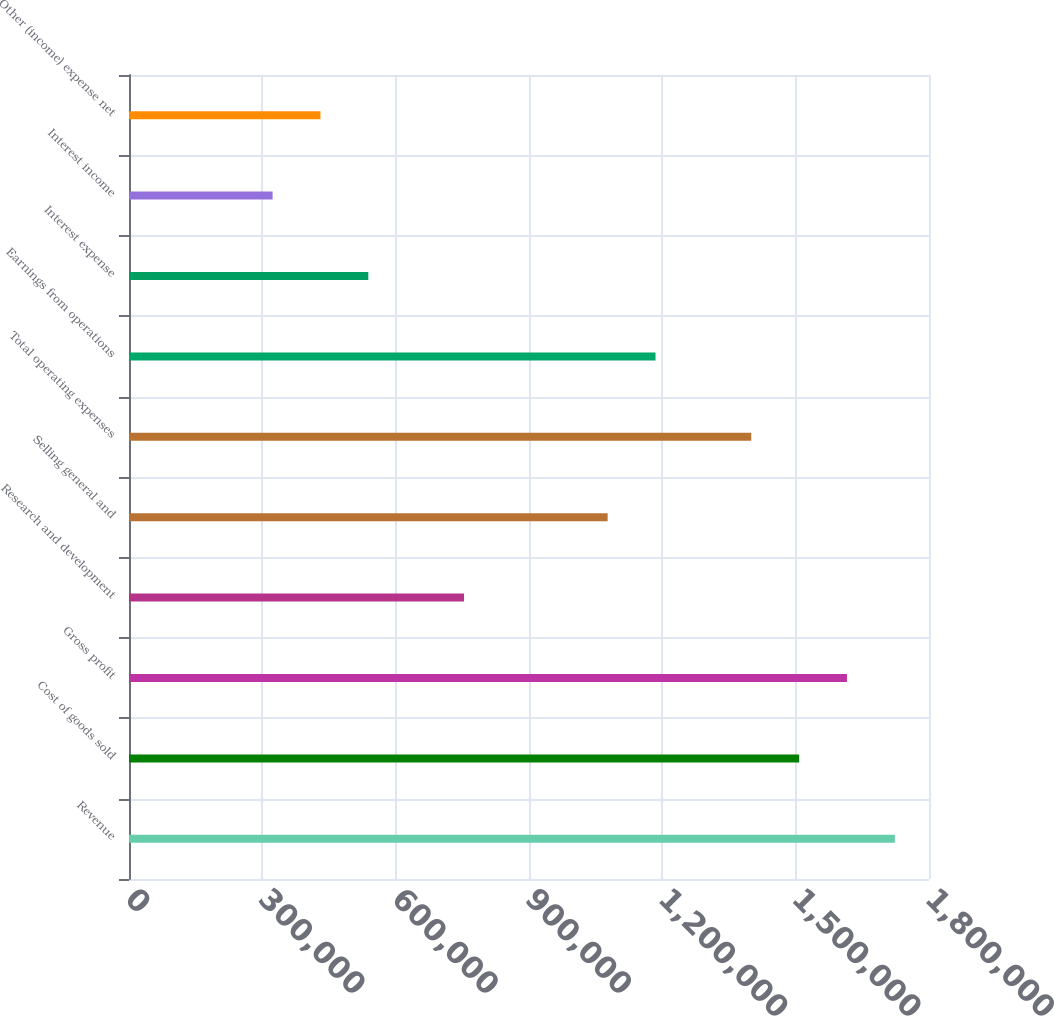Convert chart. <chart><loc_0><loc_0><loc_500><loc_500><bar_chart><fcel>Revenue<fcel>Cost of goods sold<fcel>Gross profit<fcel>Research and development<fcel>Selling general and<fcel>Total operating expenses<fcel>Earnings from operations<fcel>Interest expense<fcel>Interest income<fcel>Other (income) expense net<nl><fcel>1.72316e+06<fcel>1.50776e+06<fcel>1.61546e+06<fcel>753882<fcel>1.07697e+06<fcel>1.40007e+06<fcel>1.18467e+06<fcel>538488<fcel>323093<fcel>430790<nl></chart> 